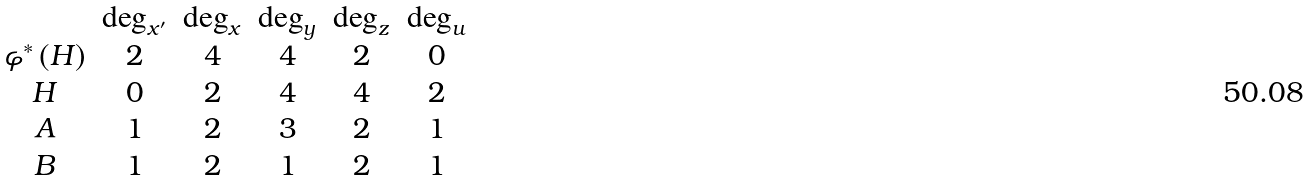Convert formula to latex. <formula><loc_0><loc_0><loc_500><loc_500>\begin{array} { c c c c c c } & \deg _ { x ^ { \prime } } & \deg _ { x } & \deg _ { y } & \deg _ { z } & \deg _ { u } \\ \varphi ^ { * } \left ( H \right ) & 2 & 4 & 4 & 2 & 0 \\ H & 0 & 2 & 4 & 4 & 2 \\ A & 1 & 2 & 3 & 2 & 1 \\ B & 1 & 2 & 1 & 2 & 1 \end{array}</formula> 